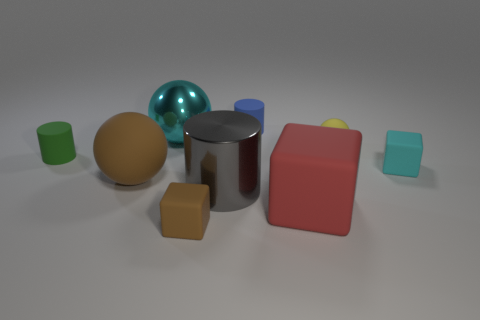How big is the ball that is in front of the big cyan thing and left of the red matte thing?
Your answer should be very brief. Large. Do the cyan matte object and the yellow ball have the same size?
Offer a very short reply. Yes. There is a small block right of the small brown cube; is its color the same as the metal ball?
Your response must be concise. Yes. What number of red things are in front of the yellow rubber ball?
Your answer should be very brief. 1. Is the number of large blocks greater than the number of gray balls?
Provide a short and direct response. Yes. There is a object that is in front of the small blue cylinder and behind the tiny yellow rubber ball; what is its shape?
Offer a terse response. Sphere. Are there any brown rubber objects?
Keep it short and to the point. Yes. There is a big cyan thing that is the same shape as the yellow rubber object; what is it made of?
Your response must be concise. Metal. The big metallic thing in front of the matte cylinder on the left side of the metallic object behind the small green cylinder is what shape?
Make the answer very short. Cylinder. There is a block that is the same color as the metallic ball; what is it made of?
Provide a short and direct response. Rubber. 